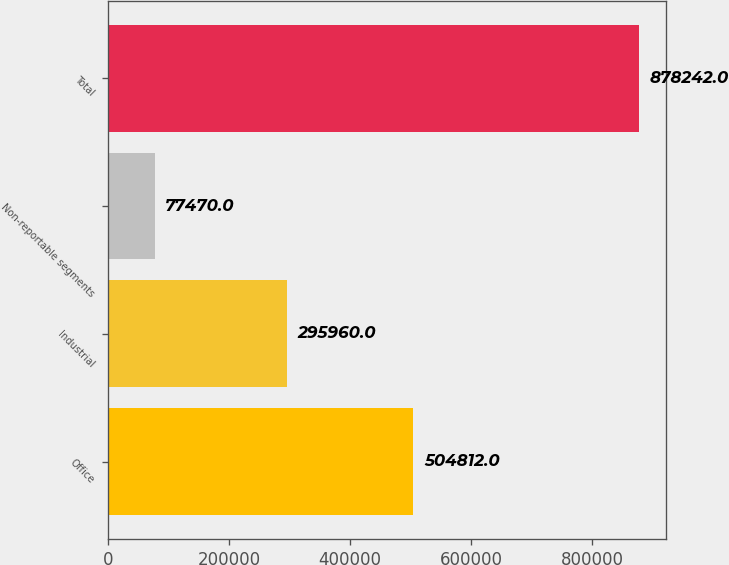<chart> <loc_0><loc_0><loc_500><loc_500><bar_chart><fcel>Office<fcel>Industrial<fcel>Non-reportable segments<fcel>Total<nl><fcel>504812<fcel>295960<fcel>77470<fcel>878242<nl></chart> 